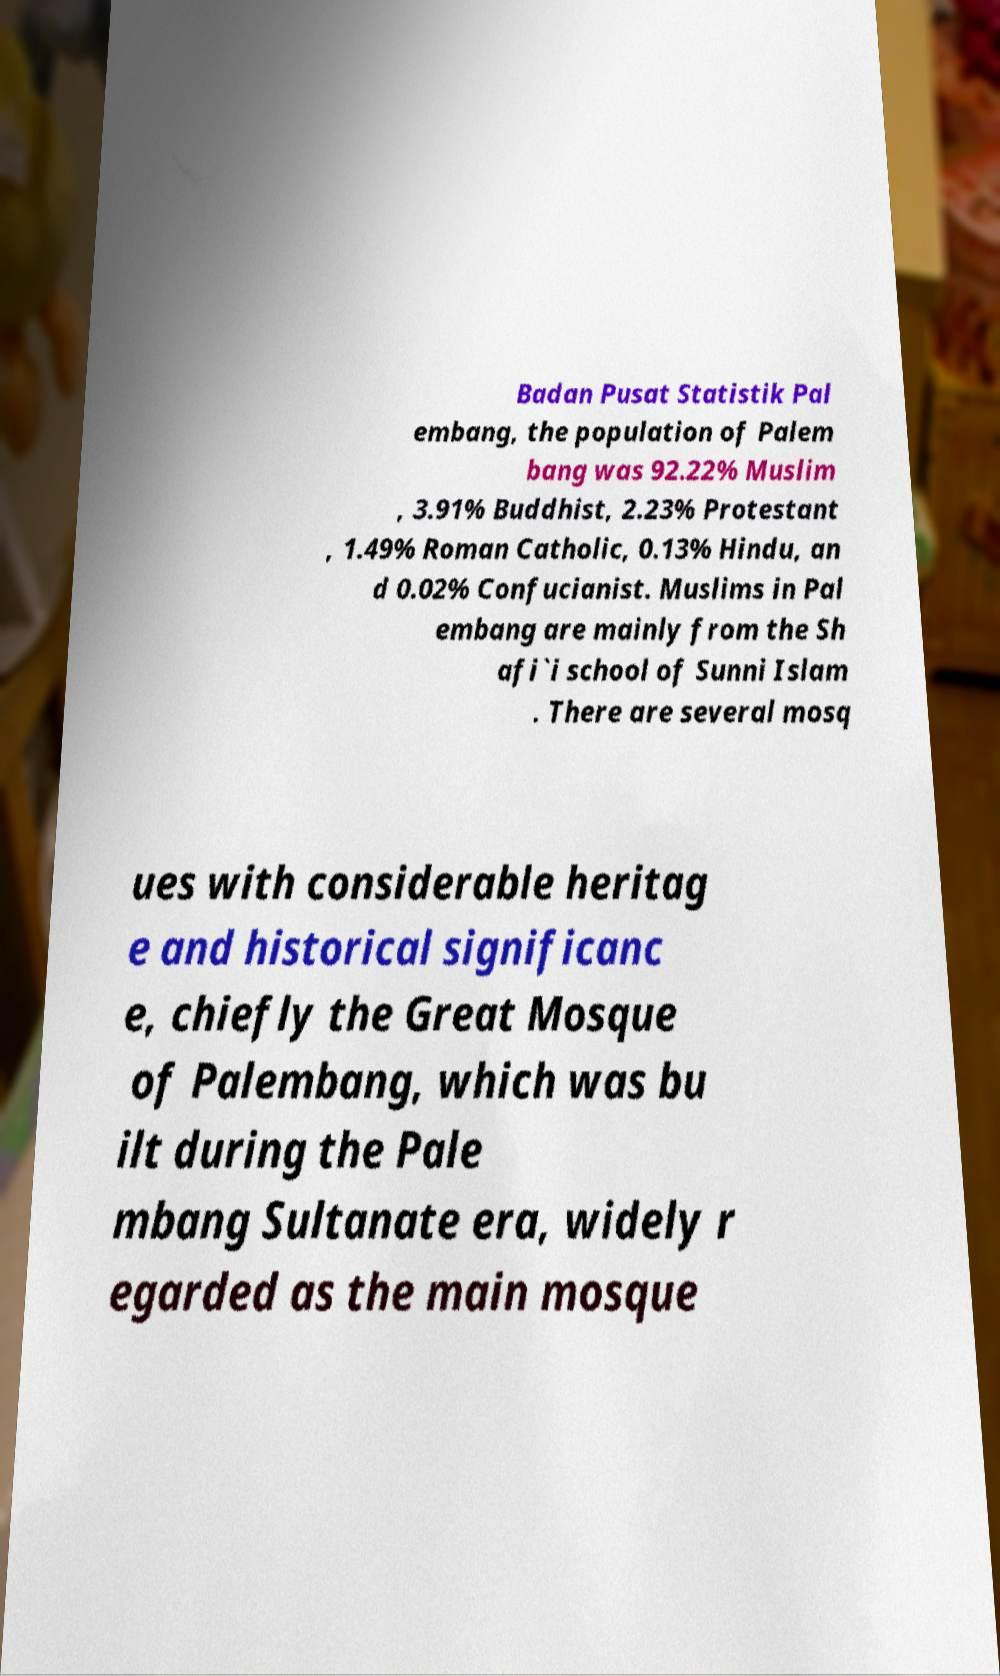What messages or text are displayed in this image? I need them in a readable, typed format. Badan Pusat Statistik Pal embang, the population of Palem bang was 92.22% Muslim , 3.91% Buddhist, 2.23% Protestant , 1.49% Roman Catholic, 0.13% Hindu, an d 0.02% Confucianist. Muslims in Pal embang are mainly from the Sh afi`i school of Sunni Islam . There are several mosq ues with considerable heritag e and historical significanc e, chiefly the Great Mosque of Palembang, which was bu ilt during the Pale mbang Sultanate era, widely r egarded as the main mosque 